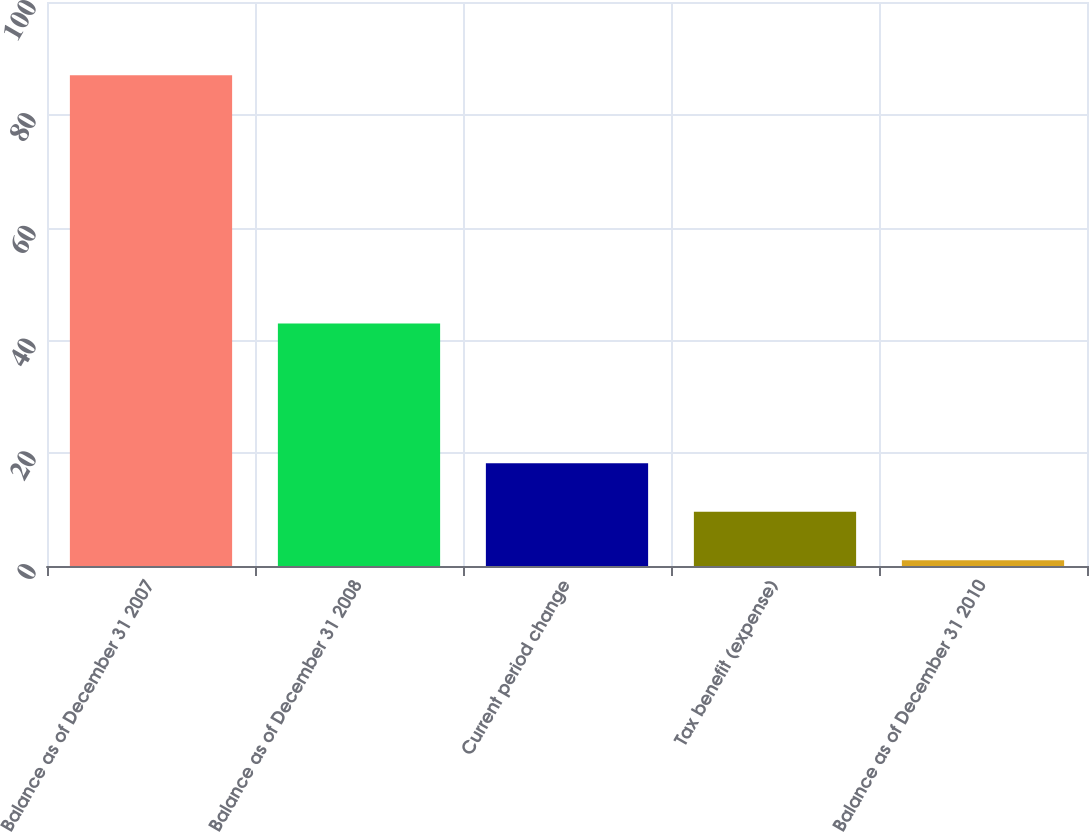<chart> <loc_0><loc_0><loc_500><loc_500><bar_chart><fcel>Balance as of December 31 2007<fcel>Balance as of December 31 2008<fcel>Current period change<fcel>Tax benefit (expense)<fcel>Balance as of December 31 2010<nl><fcel>87<fcel>43<fcel>18.2<fcel>9.6<fcel>1<nl></chart> 